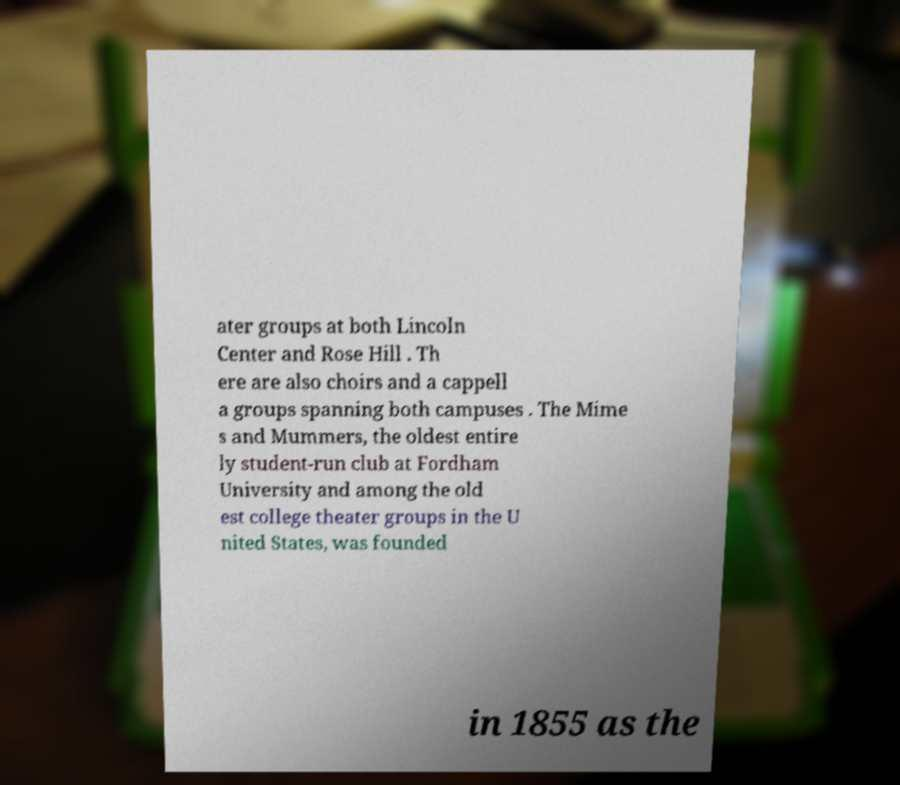There's text embedded in this image that I need extracted. Can you transcribe it verbatim? ater groups at both Lincoln Center and Rose Hill . Th ere are also choirs and a cappell a groups spanning both campuses . The Mime s and Mummers, the oldest entire ly student-run club at Fordham University and among the old est college theater groups in the U nited States, was founded in 1855 as the 